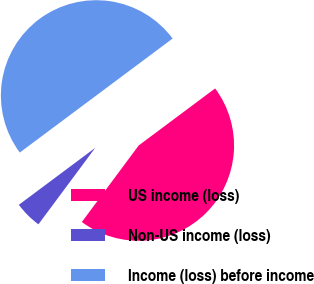<chart> <loc_0><loc_0><loc_500><loc_500><pie_chart><fcel>US income (loss)<fcel>Non-US income (loss)<fcel>Income (loss) before income<nl><fcel>45.37%<fcel>4.63%<fcel>50.0%<nl></chart> 